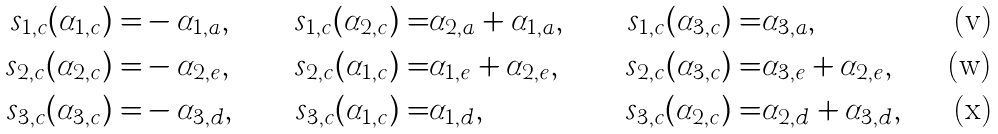<formula> <loc_0><loc_0><loc_500><loc_500>\ s _ { 1 , c } ( \alpha _ { 1 , c } ) = & - \alpha _ { 1 , a } , & \ s _ { 1 , c } ( \alpha _ { 2 , c } ) = & \alpha _ { 2 , a } + \alpha _ { 1 , a } , & \ s _ { 1 , c } ( \alpha _ { 3 , c } ) = & \alpha _ { 3 , a } , \\ \ s _ { 2 , c } ( \alpha _ { 2 , c } ) = & - \alpha _ { 2 , e } , & \ s _ { 2 , c } ( \alpha _ { 1 , c } ) = & \alpha _ { 1 , e } + \alpha _ { 2 , e } , & \ s _ { 2 , c } ( \alpha _ { 3 , c } ) = & \alpha _ { 3 , e } + \alpha _ { 2 , e } , \\ \ s _ { 3 , c } ( \alpha _ { 3 , c } ) = & - \alpha _ { 3 , d } , & \ s _ { 3 , c } ( \alpha _ { 1 , c } ) = & \alpha _ { 1 , d } , & \ s _ { 3 , c } ( \alpha _ { 2 , c } ) = & \alpha _ { 2 , d } + \alpha _ { 3 , d } ,</formula> 